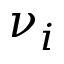Convert formula to latex. <formula><loc_0><loc_0><loc_500><loc_500>\nu _ { i }</formula> 